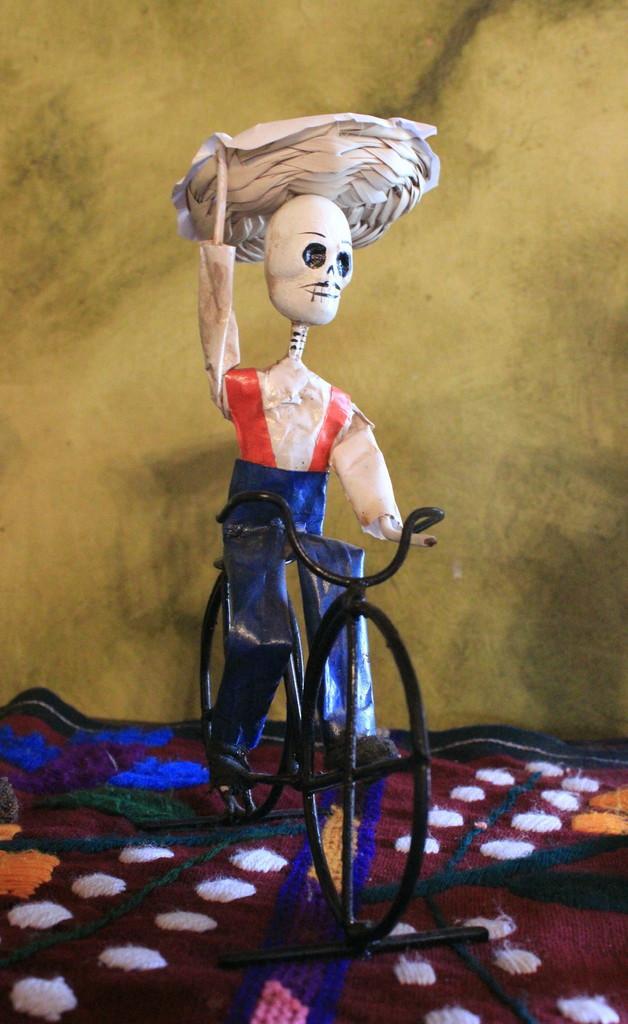Could you give a brief overview of what you see in this image? To the bottom of the image there is a maroon cloth with embroidery work on it. And in the middle of cloth there is a black toy cycle with a toy is sitting on it. In the background there is a wall. 